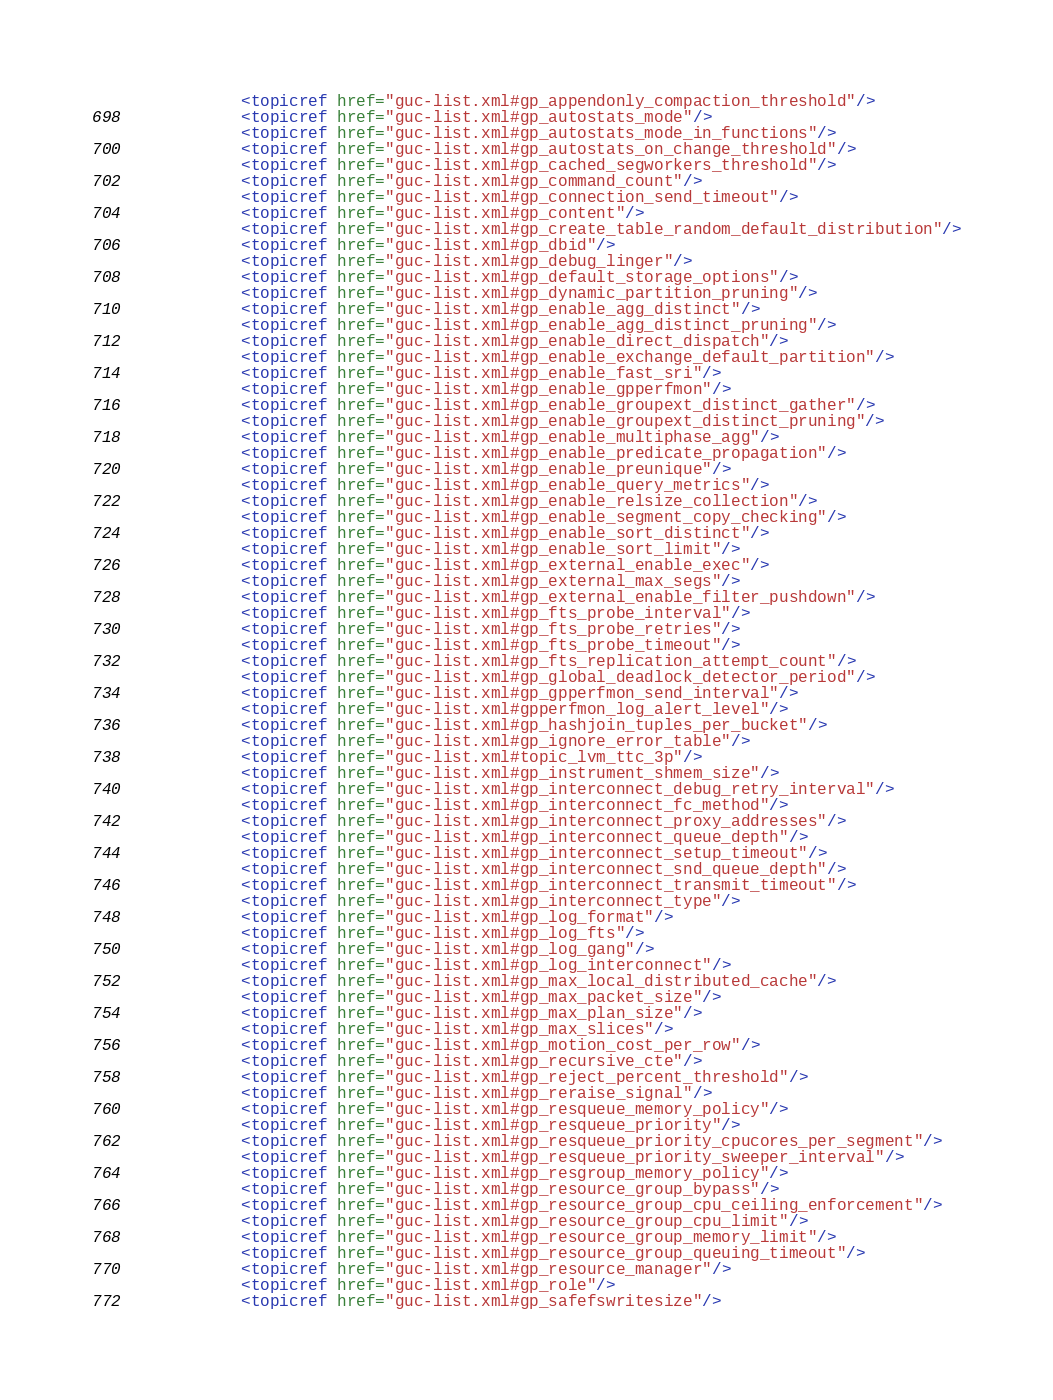<code> <loc_0><loc_0><loc_500><loc_500><_XML_>            <topicref href="guc-list.xml#gp_appendonly_compaction_threshold"/>
            <topicref href="guc-list.xml#gp_autostats_mode"/>
            <topicref href="guc-list.xml#gp_autostats_mode_in_functions"/>
            <topicref href="guc-list.xml#gp_autostats_on_change_threshold"/>
            <topicref href="guc-list.xml#gp_cached_segworkers_threshold"/>
            <topicref href="guc-list.xml#gp_command_count"/>
            <topicref href="guc-list.xml#gp_connection_send_timeout"/>
            <topicref href="guc-list.xml#gp_content"/>
            <topicref href="guc-list.xml#gp_create_table_random_default_distribution"/>
            <topicref href="guc-list.xml#gp_dbid"/>
            <topicref href="guc-list.xml#gp_debug_linger"/>
            <topicref href="guc-list.xml#gp_default_storage_options"/>
            <topicref href="guc-list.xml#gp_dynamic_partition_pruning"/>
            <topicref href="guc-list.xml#gp_enable_agg_distinct"/>
            <topicref href="guc-list.xml#gp_enable_agg_distinct_pruning"/>
            <topicref href="guc-list.xml#gp_enable_direct_dispatch"/>
            <topicref href="guc-list.xml#gp_enable_exchange_default_partition"/>
            <topicref href="guc-list.xml#gp_enable_fast_sri"/>
            <topicref href="guc-list.xml#gp_enable_gpperfmon"/>
            <topicref href="guc-list.xml#gp_enable_groupext_distinct_gather"/>
            <topicref href="guc-list.xml#gp_enable_groupext_distinct_pruning"/>
            <topicref href="guc-list.xml#gp_enable_multiphase_agg"/>
            <topicref href="guc-list.xml#gp_enable_predicate_propagation"/>
            <topicref href="guc-list.xml#gp_enable_preunique"/>
            <topicref href="guc-list.xml#gp_enable_query_metrics"/>
            <topicref href="guc-list.xml#gp_enable_relsize_collection"/>
            <topicref href="guc-list.xml#gp_enable_segment_copy_checking"/>
            <topicref href="guc-list.xml#gp_enable_sort_distinct"/>
            <topicref href="guc-list.xml#gp_enable_sort_limit"/>
            <topicref href="guc-list.xml#gp_external_enable_exec"/>
            <topicref href="guc-list.xml#gp_external_max_segs"/>
            <topicref href="guc-list.xml#gp_external_enable_filter_pushdown"/>
            <topicref href="guc-list.xml#gp_fts_probe_interval"/>
            <topicref href="guc-list.xml#gp_fts_probe_retries"/>
            <topicref href="guc-list.xml#gp_fts_probe_timeout"/>
            <topicref href="guc-list.xml#gp_fts_replication_attempt_count"/>
            <topicref href="guc-list.xml#gp_global_deadlock_detector_period"/>
            <topicref href="guc-list.xml#gp_gpperfmon_send_interval"/>
            <topicref href="guc-list.xml#gpperfmon_log_alert_level"/>
            <topicref href="guc-list.xml#gp_hashjoin_tuples_per_bucket"/>
            <topicref href="guc-list.xml#gp_ignore_error_table"/>
            <topicref href="guc-list.xml#topic_lvm_ttc_3p"/>
            <topicref href="guc-list.xml#gp_instrument_shmem_size"/>
            <topicref href="guc-list.xml#gp_interconnect_debug_retry_interval"/>
            <topicref href="guc-list.xml#gp_interconnect_fc_method"/>
            <topicref href="guc-list.xml#gp_interconnect_proxy_addresses"/>
            <topicref href="guc-list.xml#gp_interconnect_queue_depth"/>
            <topicref href="guc-list.xml#gp_interconnect_setup_timeout"/>
            <topicref href="guc-list.xml#gp_interconnect_snd_queue_depth"/>
            <topicref href="guc-list.xml#gp_interconnect_transmit_timeout"/>
            <topicref href="guc-list.xml#gp_interconnect_type"/>
            <topicref href="guc-list.xml#gp_log_format"/>
            <topicref href="guc-list.xml#gp_log_fts"/>
            <topicref href="guc-list.xml#gp_log_gang"/>
            <topicref href="guc-list.xml#gp_log_interconnect"/>
            <topicref href="guc-list.xml#gp_max_local_distributed_cache"/>
            <topicref href="guc-list.xml#gp_max_packet_size"/>
            <topicref href="guc-list.xml#gp_max_plan_size"/>
            <topicref href="guc-list.xml#gp_max_slices"/>
            <topicref href="guc-list.xml#gp_motion_cost_per_row"/>
            <topicref href="guc-list.xml#gp_recursive_cte"/>
            <topicref href="guc-list.xml#gp_reject_percent_threshold"/>
            <topicref href="guc-list.xml#gp_reraise_signal"/>
            <topicref href="guc-list.xml#gp_resqueue_memory_policy"/>
            <topicref href="guc-list.xml#gp_resqueue_priority"/>
            <topicref href="guc-list.xml#gp_resqueue_priority_cpucores_per_segment"/>
            <topicref href="guc-list.xml#gp_resqueue_priority_sweeper_interval"/>
            <topicref href="guc-list.xml#gp_resgroup_memory_policy"/>
            <topicref href="guc-list.xml#gp_resource_group_bypass"/>
            <topicref href="guc-list.xml#gp_resource_group_cpu_ceiling_enforcement"/>
            <topicref href="guc-list.xml#gp_resource_group_cpu_limit"/>
            <topicref href="guc-list.xml#gp_resource_group_memory_limit"/>
            <topicref href="guc-list.xml#gp_resource_group_queuing_timeout"/>
            <topicref href="guc-list.xml#gp_resource_manager"/>
            <topicref href="guc-list.xml#gp_role"/>
            <topicref href="guc-list.xml#gp_safefswritesize"/></code> 